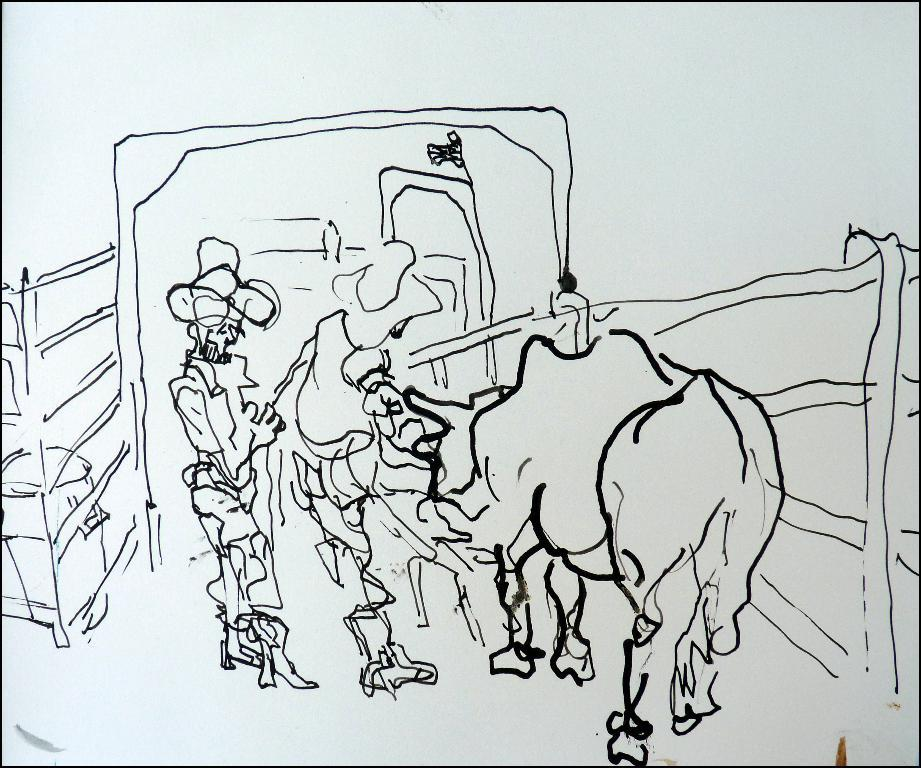What is the primary element of the image? The image contains a sketch. What color is used for the sketch? The sketch is drawn with black color. What types of subjects are depicted in the sketch? There is an animal and a person in the sketch. What color is used for the background of the sketch? The background of the sketch is in white color. Can you tell me how many pails are used for humor in the sketch? There are no pails or references to humor in the sketch; it is a simple drawing of an animal and a person. 